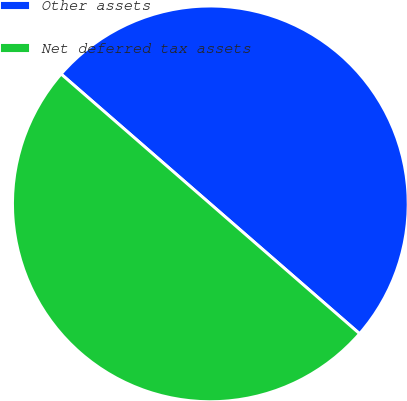<chart> <loc_0><loc_0><loc_500><loc_500><pie_chart><fcel>Other assets<fcel>Net deferred tax assets<nl><fcel>50.0%<fcel>50.0%<nl></chart> 